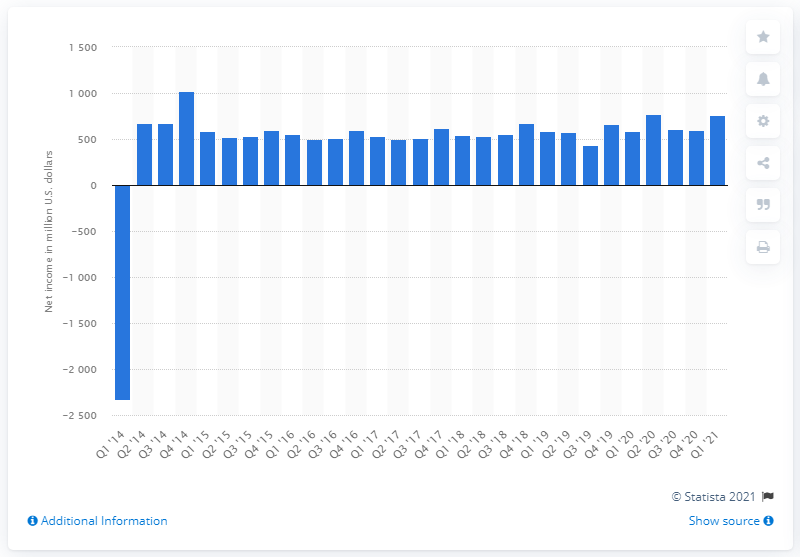Draw attention to some important aspects in this diagram. eBay's net revenue in the most recent quarter of 2021 was approximately $586 million. Ebay reported a net income of $586 million in the first quarter of 2021. eBay reported a net income of $758 million in the first quarter of 2021. 